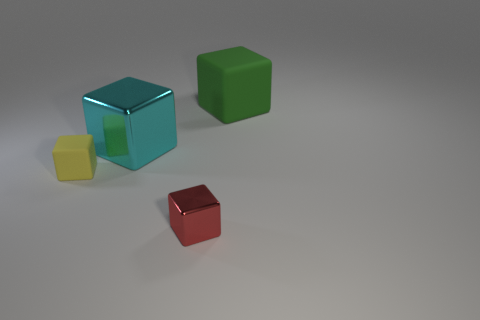Are there any other things that have the same color as the big metallic thing?
Your answer should be compact. No. There is a yellow object that is the same shape as the red metal object; what material is it?
Offer a terse response. Rubber. What number of other things are the same size as the cyan metal block?
Keep it short and to the point. 1. What is the small red object made of?
Offer a terse response. Metal. Is the number of cubes right of the yellow object greater than the number of shiny cubes?
Provide a succinct answer. Yes. Is there a large green block?
Your response must be concise. Yes. What number of other objects are there of the same shape as the cyan object?
Provide a short and direct response. 3. What size is the matte block in front of the rubber block that is right of the thing that is on the left side of the cyan shiny block?
Your answer should be very brief. Small. There is a object that is in front of the cyan block and to the right of the yellow matte cube; what is its shape?
Offer a terse response. Cube. Are there an equal number of green things in front of the large metallic cube and green objects behind the green block?
Give a very brief answer. Yes. 